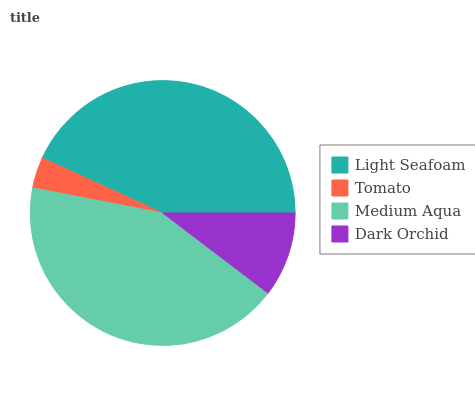Is Tomato the minimum?
Answer yes or no. Yes. Is Light Seafoam the maximum?
Answer yes or no. Yes. Is Medium Aqua the minimum?
Answer yes or no. No. Is Medium Aqua the maximum?
Answer yes or no. No. Is Medium Aqua greater than Tomato?
Answer yes or no. Yes. Is Tomato less than Medium Aqua?
Answer yes or no. Yes. Is Tomato greater than Medium Aqua?
Answer yes or no. No. Is Medium Aqua less than Tomato?
Answer yes or no. No. Is Medium Aqua the high median?
Answer yes or no. Yes. Is Dark Orchid the low median?
Answer yes or no. Yes. Is Tomato the high median?
Answer yes or no. No. Is Tomato the low median?
Answer yes or no. No. 